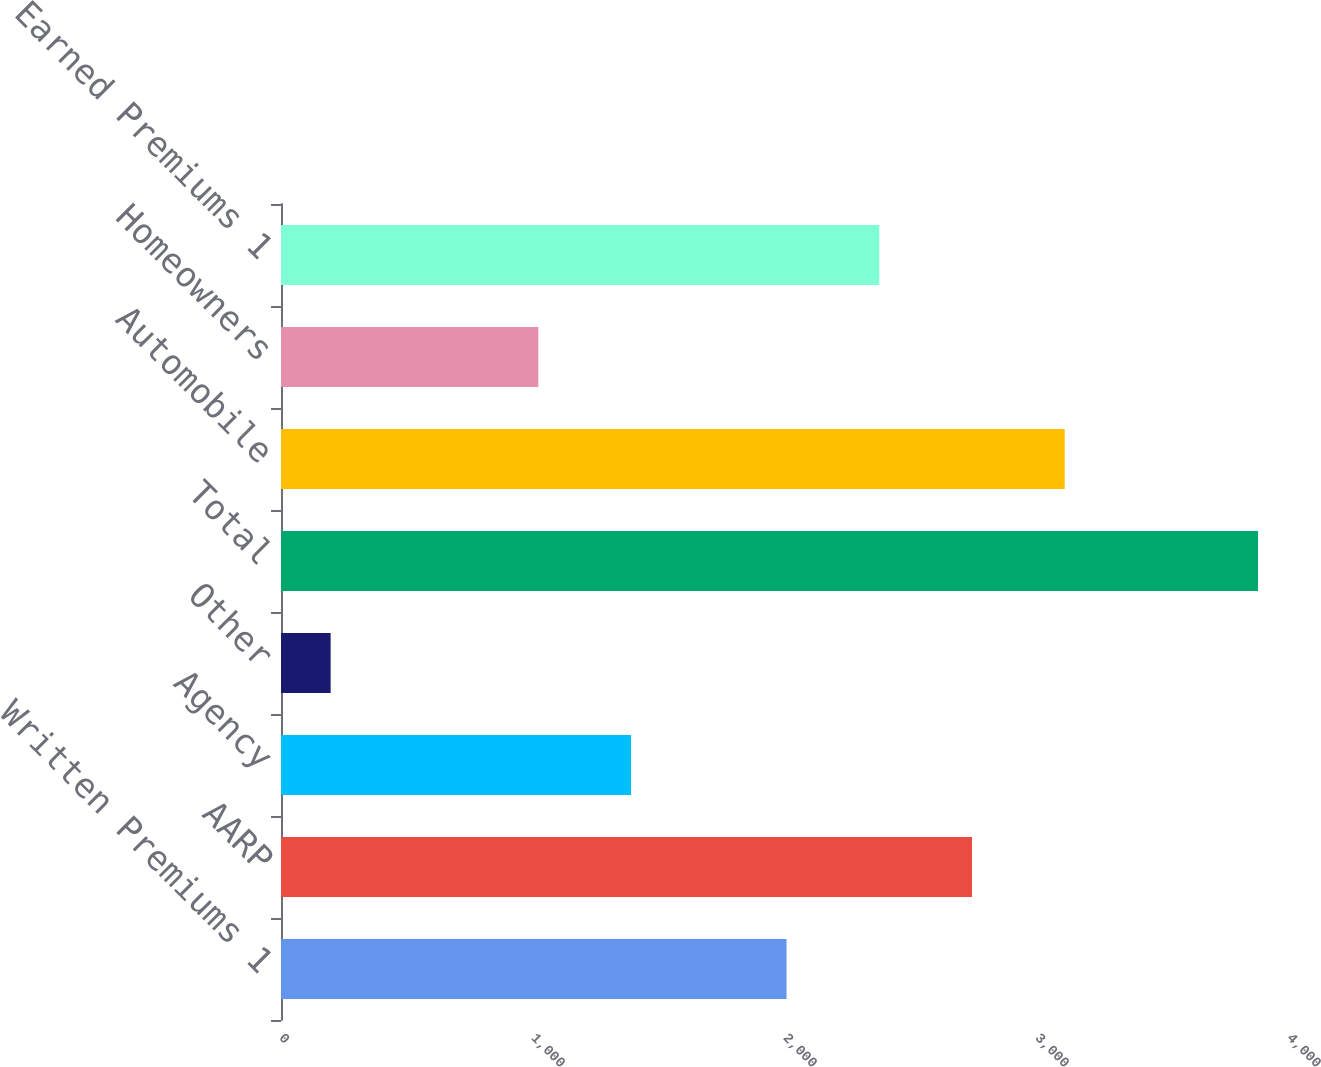Convert chart to OTSL. <chart><loc_0><loc_0><loc_500><loc_500><bar_chart><fcel>Written Premiums 1<fcel>AARP<fcel>Agency<fcel>Other<fcel>Total<fcel>Automobile<fcel>Homeowners<fcel>Earned Premiums 1<nl><fcel>2006<fcel>2742<fcel>1389<fcel>197<fcel>3877<fcel>3110<fcel>1021<fcel>2374<nl></chart> 